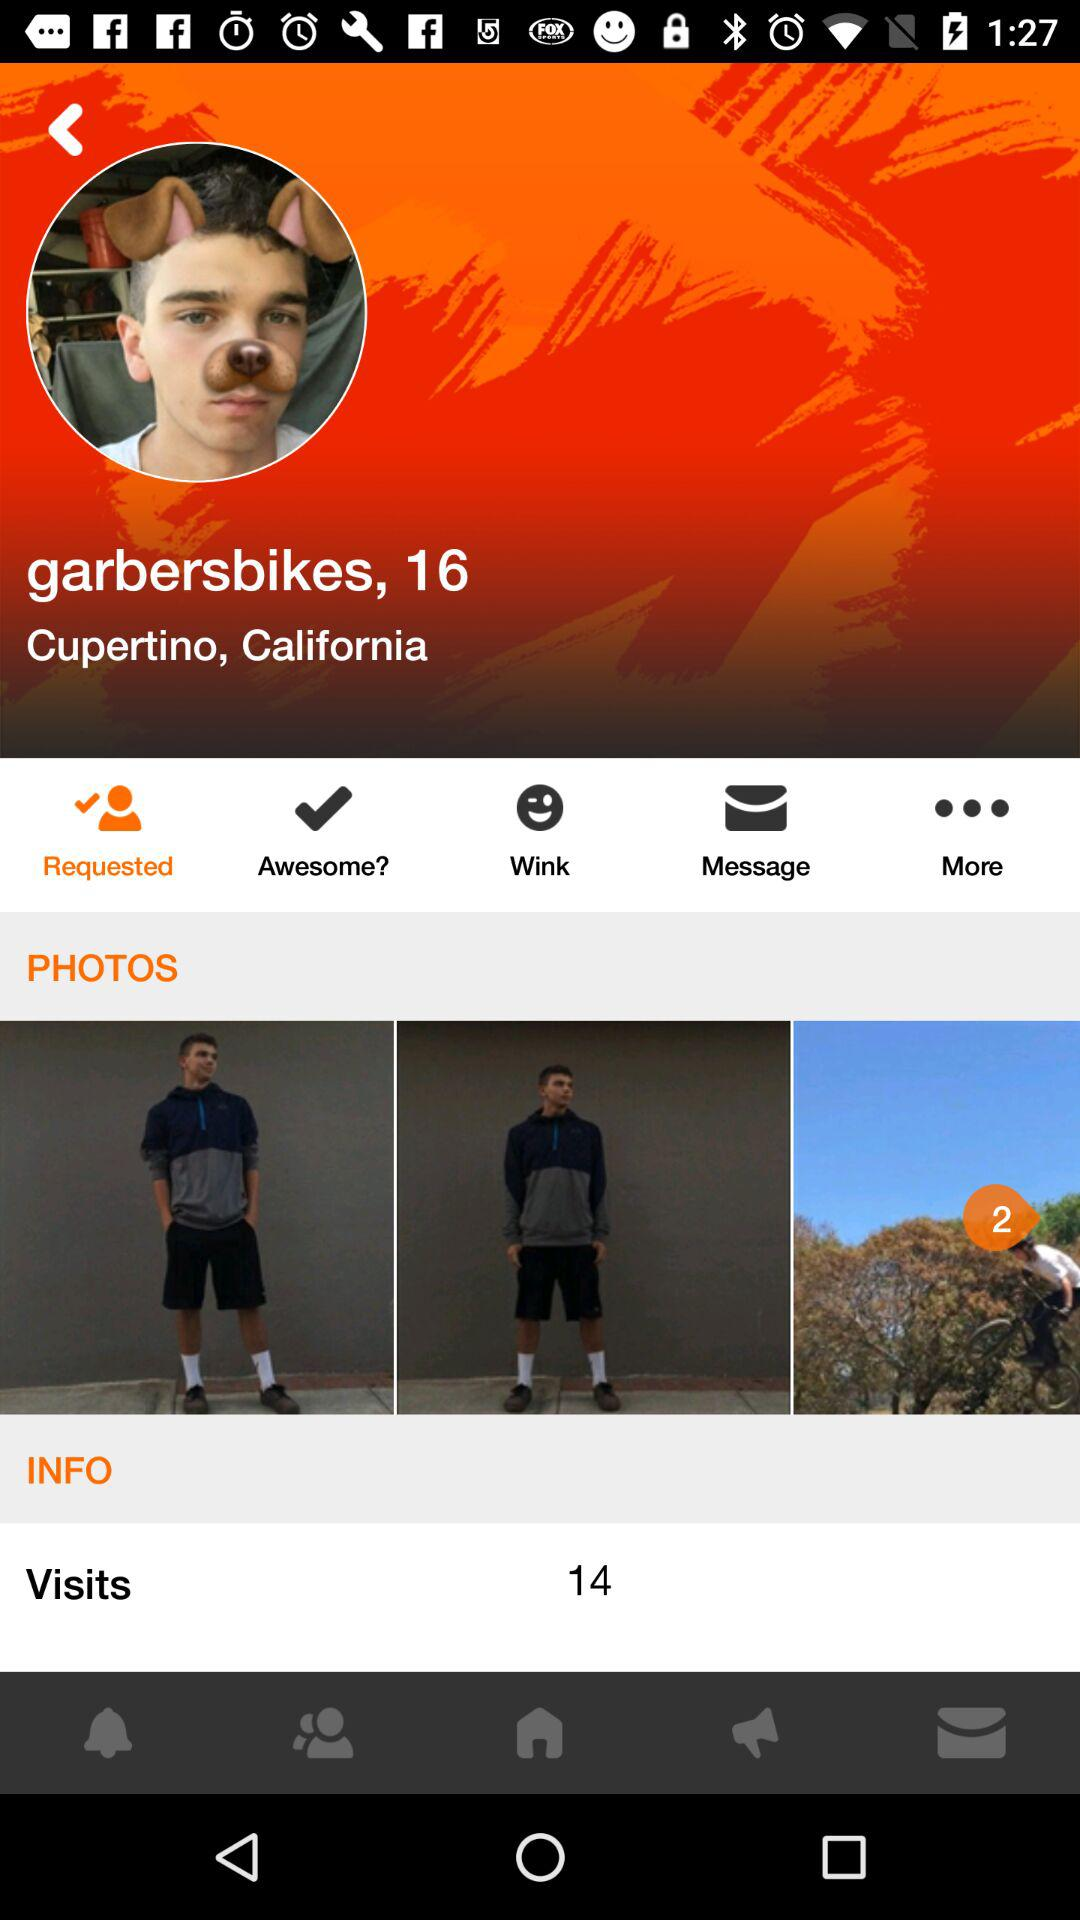What is the username? The username is "garbersbikes". 